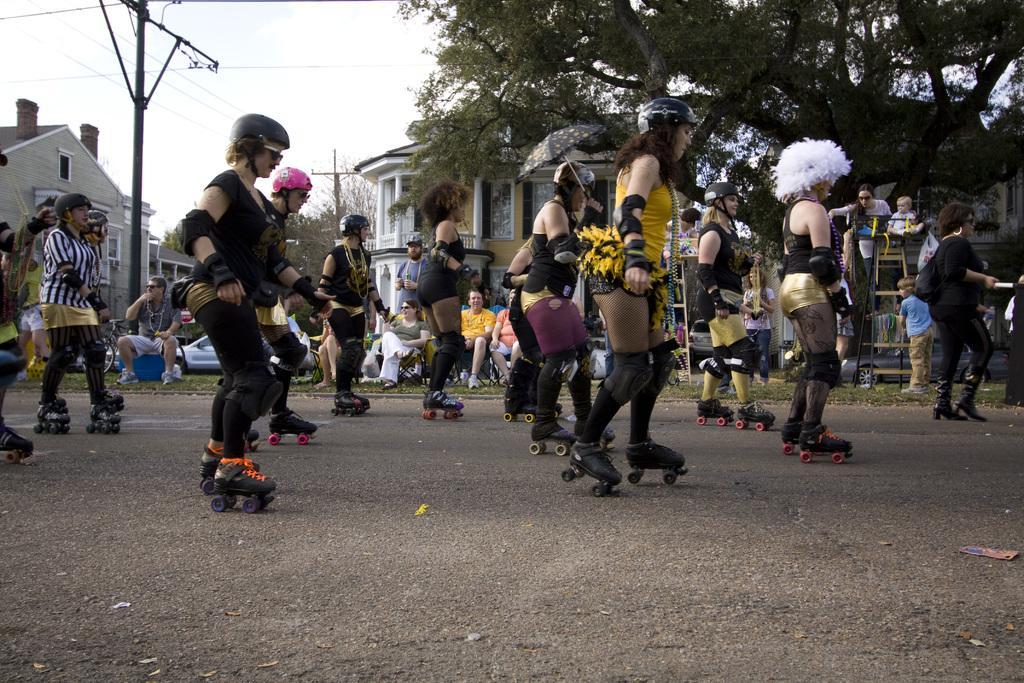In one or two sentences, can you explain what this image depicts? In this picture I can see few people wore helmets on their heads and they wore skates to their legs and I can see buildings and trees and couple of poles and I can see few people seated on the chairs and few cars parked and a cloudy sky. 